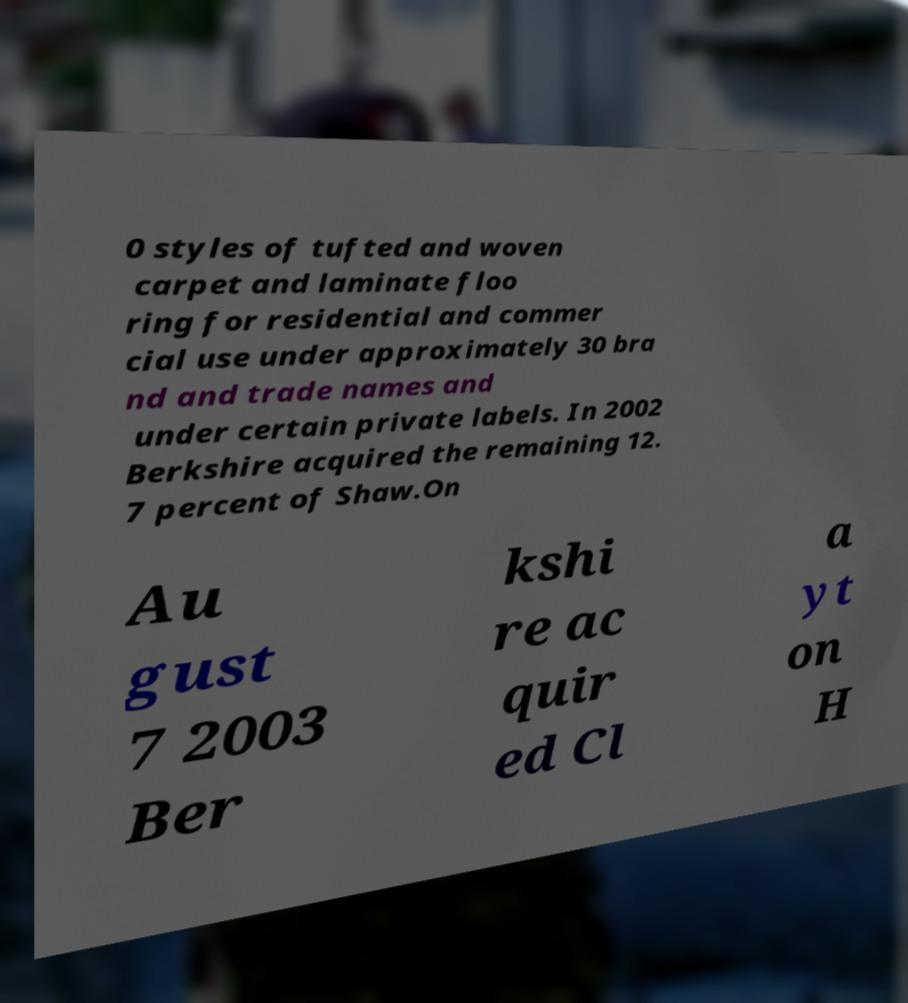Please read and relay the text visible in this image. What does it say? 0 styles of tufted and woven carpet and laminate floo ring for residential and commer cial use under approximately 30 bra nd and trade names and under certain private labels. In 2002 Berkshire acquired the remaining 12. 7 percent of Shaw.On Au gust 7 2003 Ber kshi re ac quir ed Cl a yt on H 